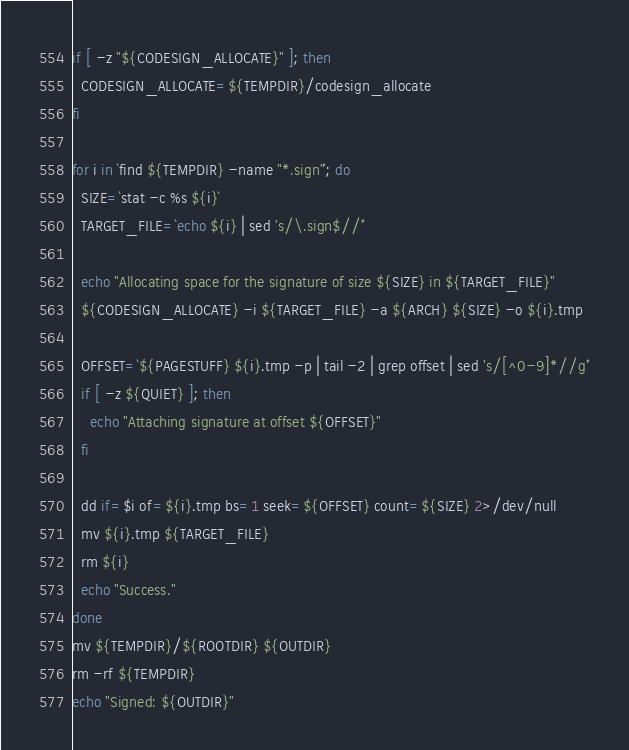Convert code to text. <code><loc_0><loc_0><loc_500><loc_500><_Bash_>
if [ -z "${CODESIGN_ALLOCATE}" ]; then
  CODESIGN_ALLOCATE=${TEMPDIR}/codesign_allocate
fi

for i in `find ${TEMPDIR} -name "*.sign"`; do
  SIZE=`stat -c %s ${i}`
  TARGET_FILE=`echo ${i} | sed 's/\.sign$//'`

  echo "Allocating space for the signature of size ${SIZE} in ${TARGET_FILE}"
  ${CODESIGN_ALLOCATE} -i ${TARGET_FILE} -a ${ARCH} ${SIZE} -o ${i}.tmp

  OFFSET=`${PAGESTUFF} ${i}.tmp -p | tail -2 | grep offset | sed 's/[^0-9]*//g'`
  if [ -z ${QUIET} ]; then
    echo "Attaching signature at offset ${OFFSET}"
  fi

  dd if=$i of=${i}.tmp bs=1 seek=${OFFSET} count=${SIZE} 2>/dev/null
  mv ${i}.tmp ${TARGET_FILE}
  rm ${i}
  echo "Success."
done
mv ${TEMPDIR}/${ROOTDIR} ${OUTDIR}
rm -rf ${TEMPDIR}
echo "Signed: ${OUTDIR}"
</code> 